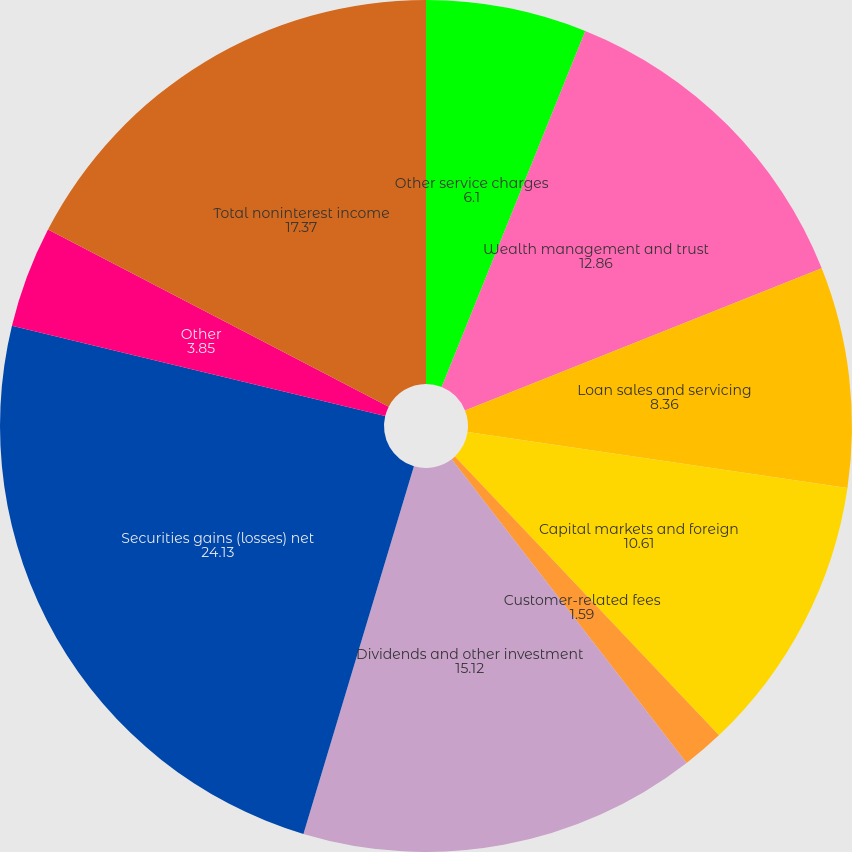Convert chart to OTSL. <chart><loc_0><loc_0><loc_500><loc_500><pie_chart><fcel>Other service charges<fcel>Wealth management and trust<fcel>Loan sales and servicing<fcel>Capital markets and foreign<fcel>Customer-related fees<fcel>Dividends and other investment<fcel>Securities gains (losses) net<fcel>Other<fcel>Total noninterest income<nl><fcel>6.1%<fcel>12.86%<fcel>8.36%<fcel>10.61%<fcel>1.59%<fcel>15.12%<fcel>24.13%<fcel>3.85%<fcel>17.37%<nl></chart> 